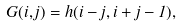Convert formula to latex. <formula><loc_0><loc_0><loc_500><loc_500>G ( i , j ) = h ( i - j , i + j - 1 ) ,</formula> 